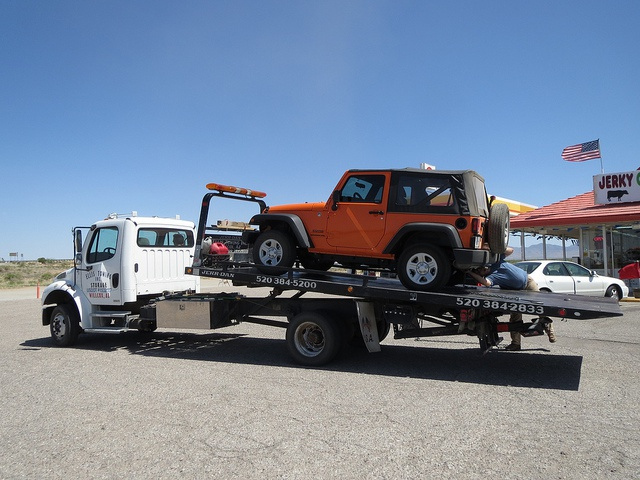Describe the objects in this image and their specific colors. I can see truck in gray, black, white, and darkgray tones, car in gray, black, and maroon tones, car in gray, white, darkgray, and blue tones, people in gray, black, navy, and darkgray tones, and people in gray, black, and darkgray tones in this image. 